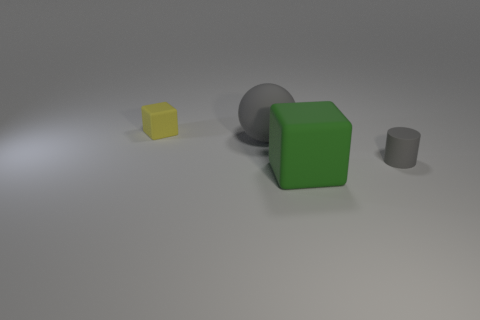Add 3 small cubes. How many objects exist? 7 Subtract all spheres. How many objects are left? 3 Add 4 large green matte cubes. How many large green matte cubes are left? 5 Add 2 small yellow matte objects. How many small yellow matte objects exist? 3 Subtract 0 cyan spheres. How many objects are left? 4 Subtract all red balls. Subtract all big gray objects. How many objects are left? 3 